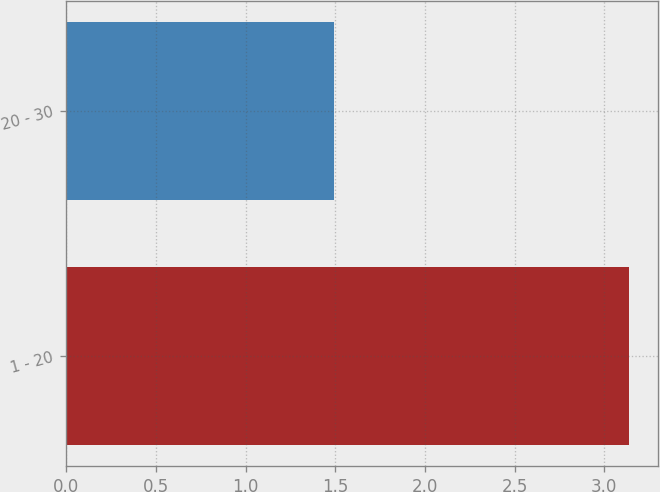Convert chart. <chart><loc_0><loc_0><loc_500><loc_500><bar_chart><fcel>1 - 20<fcel>20 - 30<nl><fcel>3.14<fcel>1.49<nl></chart> 